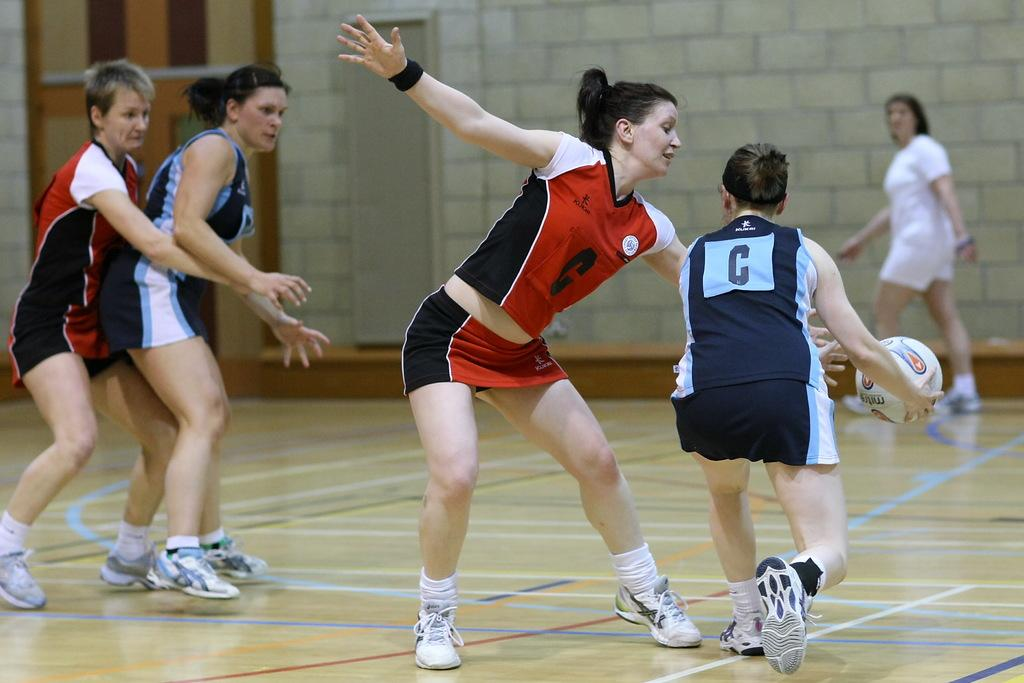<image>
Summarize the visual content of the image. A female basketball game is going on and both teams have a C on their jersey. 